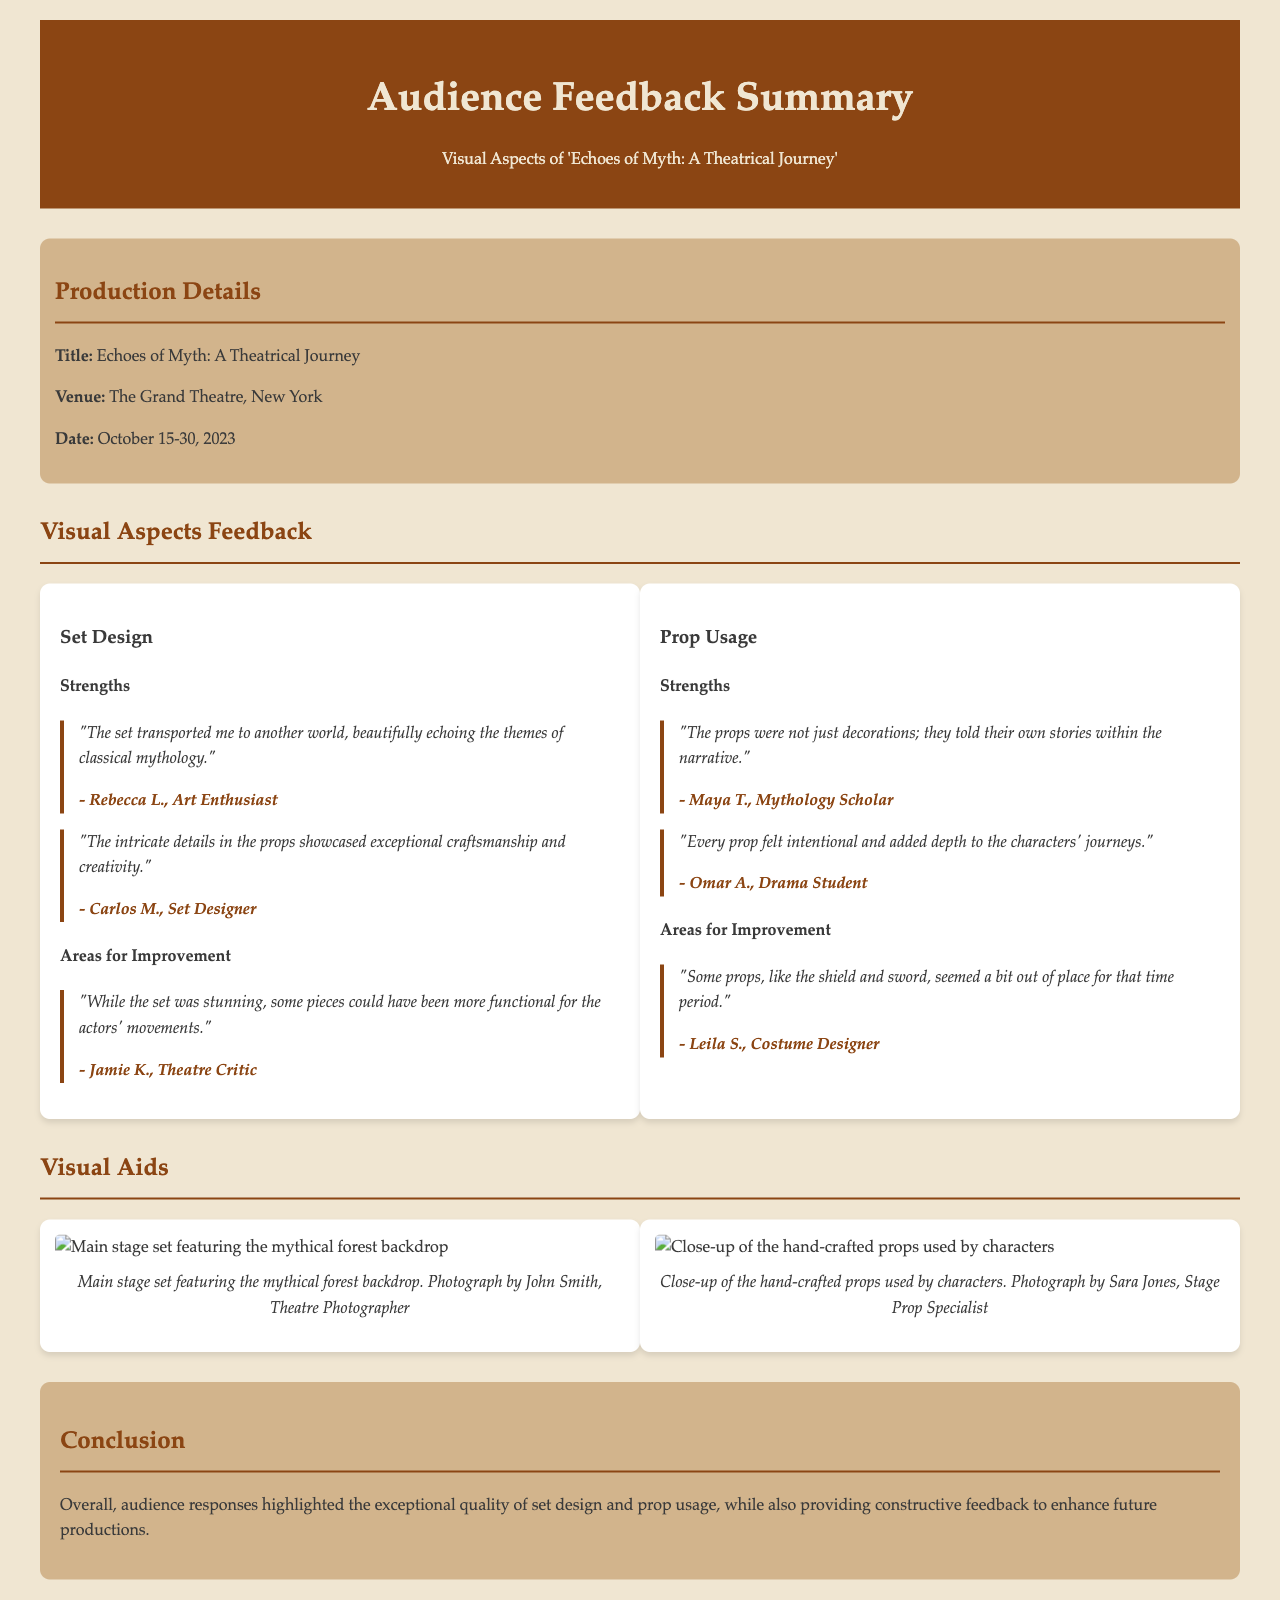What is the title of the production? The title of the production is clearly stated in the document under the production details section.
Answer: Echoes of Myth: A Theatrical Journey Where was the production held? The venue for the production is mentioned in the production details section.
Answer: The Grand Theatre, New York What date range did the production take place? The document specifies the date range in the production details section.
Answer: October 15-30, 2023 Who commented on the exceptional craftsmanship of the props? The quote attributes the comment to a specific audience member related to their profession, found in the set design strengths section.
Answer: Carlos M., Set Designer What was highlighted as a strength of the props according to Maya T.? The strengths section for prop usage contains a quote by Maya T. about the nature of the props.
Answer: They told their own stories within the narrative How many images are included in the visual aids section? The document describes the visual aids section which contains images and provides a count based on their presentation.
Answer: 2 What color scheme is used for the header background? The color of the header background is defined in the document under the header styling properties.
Answer: #8b4513 Which audience member mentioned an area for improvement regarding set functionality? The specific critique about set functionality is attributed to a particular audience member in the critiques section.
Answer: Jamie K., Theatre Critic What photograph credit is given for the close-up of the props? The visual aids section attributes the credit for the photograph in the context of the image description.
Answer: Sara Jones, Stage Prop Specialist 